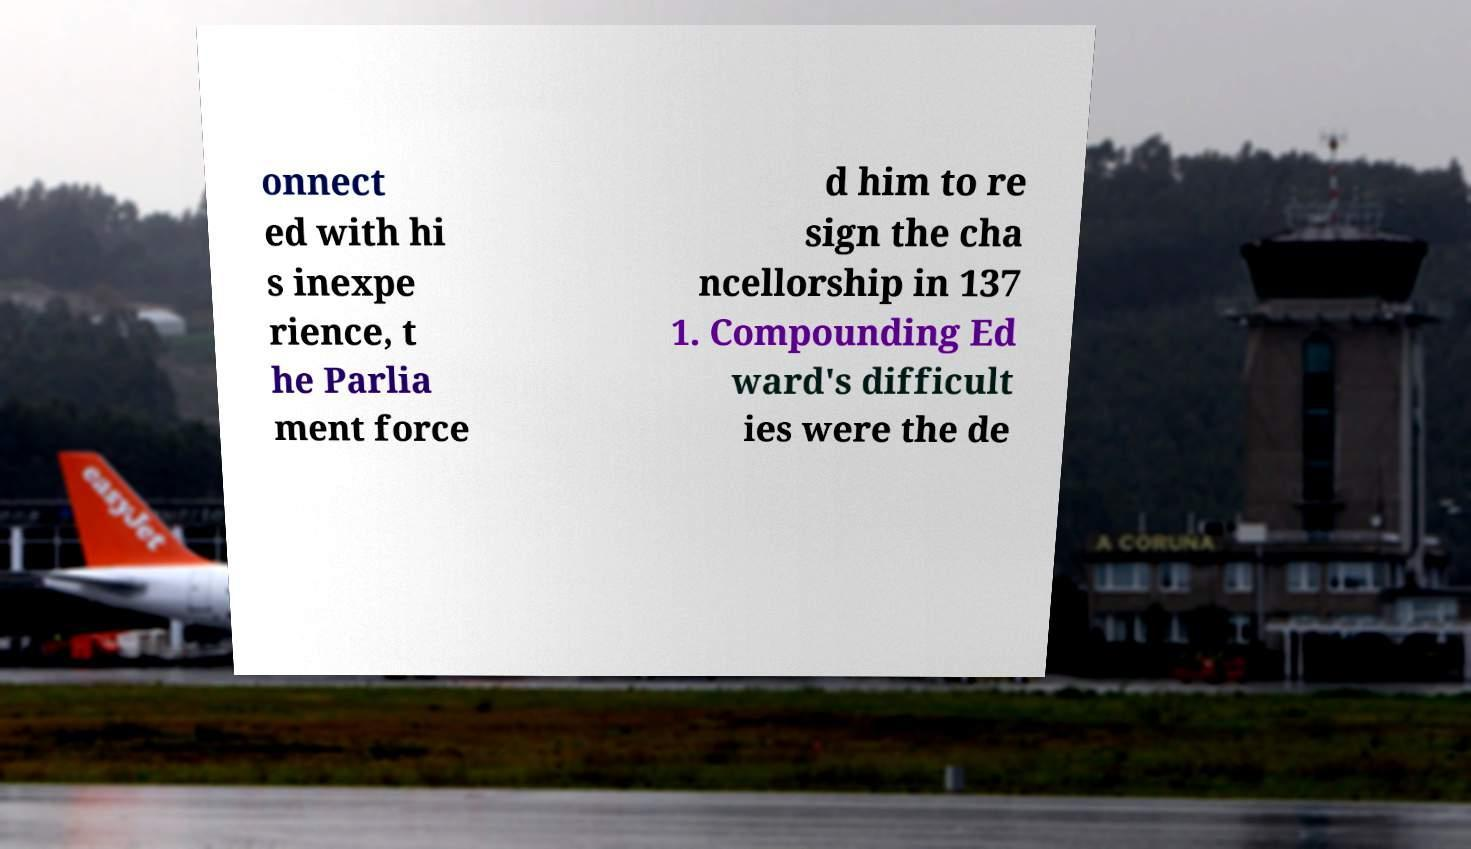What messages or text are displayed in this image? I need them in a readable, typed format. onnect ed with hi s inexpe rience, t he Parlia ment force d him to re sign the cha ncellorship in 137 1. Compounding Ed ward's difficult ies were the de 